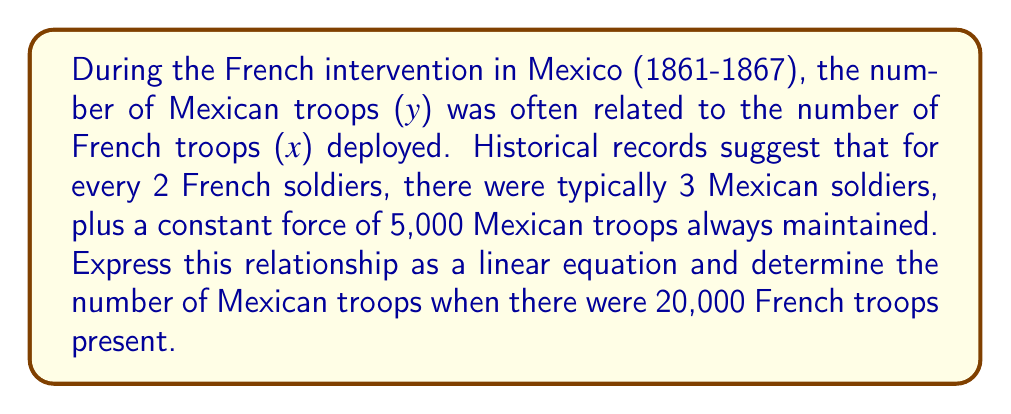Can you answer this question? Let's approach this step-by-step:

1) We're told that for every 2 French soldiers, there were 3 Mexican soldiers. This gives us the slope of our line:
   
   Slope = $\frac{3}{2}$ = 1.5

2) We're also told that there was a constant force of 5,000 Mexican troops always maintained. This is our y-intercept.

3) The general form of a linear equation is $y = mx + b$, where:
   - $y$ is the number of Mexican troops
   - $x$ is the number of French troops
   - $m$ is the slope (1.5)
   - $b$ is the y-intercept (5,000)

4) Substituting these values, our equation becomes:

   $y = 1.5x + 5000$

5) To find the number of Mexican troops when there were 20,000 French troops, we substitute $x = 20000$:

   $y = 1.5(20000) + 5000$
   $y = 30000 + 5000$
   $y = 35000$

Therefore, when there were 20,000 French troops, there would have been 35,000 Mexican troops.
Answer: $y = 1.5x + 5000$; 35,000 Mexican troops 